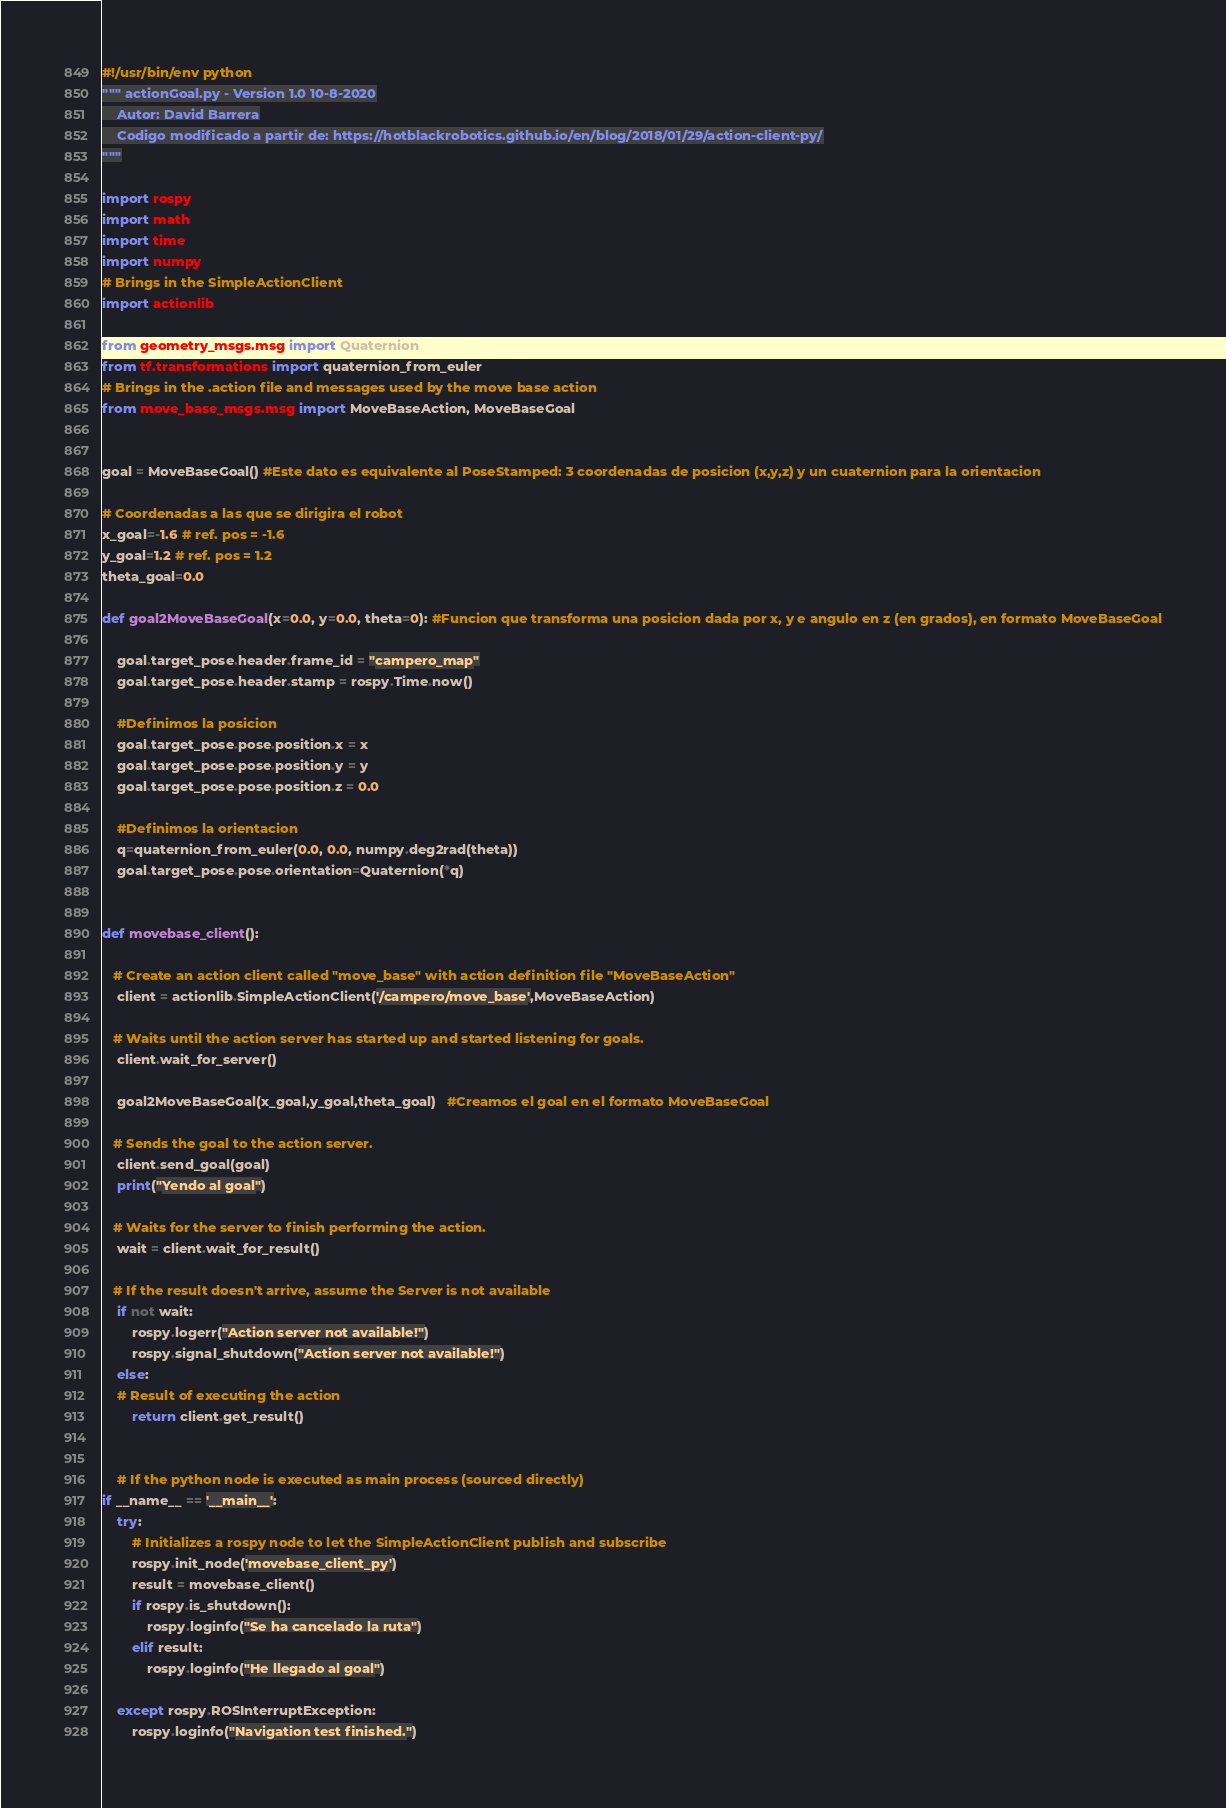<code> <loc_0><loc_0><loc_500><loc_500><_Python_>#!/usr/bin/env python
""" actionGoal.py - Version 1.0 10-8-2020
    Autor: David Barrera
    Codigo modificado a partir de: https://hotblackrobotics.github.io/en/blog/2018/01/29/action-client-py/
"""

import rospy
import math
import time
import numpy
# Brings in the SimpleActionClient
import actionlib

from geometry_msgs.msg import Quaternion
from tf.transformations import quaternion_from_euler
# Brings in the .action file and messages used by the move base action
from move_base_msgs.msg import MoveBaseAction, MoveBaseGoal


goal = MoveBaseGoal() #Este dato es equivalente al PoseStamped: 3 coordenadas de posicion (x,y,z) y un cuaternion para la orientacion

# Coordenadas a las que se dirigira el robot
x_goal=-1.6 # ref. pos = -1.6
y_goal=1.2 # ref. pos = 1.2
theta_goal=0.0

def goal2MoveBaseGoal(x=0.0, y=0.0, theta=0): #Funcion que transforma una posicion dada por x, y e angulo en z (en grados), en formato MoveBaseGoal

    goal.target_pose.header.frame_id = "campero_map"
    goal.target_pose.header.stamp = rospy.Time.now()

    #Definimos la posicion
    goal.target_pose.pose.position.x = x
    goal.target_pose.pose.position.y = y
    goal.target_pose.pose.position.z = 0.0

    #Definimos la orientacion
    q=quaternion_from_euler(0.0, 0.0, numpy.deg2rad(theta))
    goal.target_pose.pose.orientation=Quaternion(*q)


def movebase_client():

   # Create an action client called "move_base" with action definition file "MoveBaseAction"
    client = actionlib.SimpleActionClient('/campero/move_base',MoveBaseAction)

   # Waits until the action server has started up and started listening for goals.
    client.wait_for_server()

    goal2MoveBaseGoal(x_goal,y_goal,theta_goal)   #Creamos el goal en el formato MoveBaseGoal

   # Sends the goal to the action server.
    client.send_goal(goal)
    print("Yendo al goal")

   # Waits for the server to finish performing the action.
    wait = client.wait_for_result()
    
   # If the result doesn't arrive, assume the Server is not available
    if not wait:
        rospy.logerr("Action server not available!")
        rospy.signal_shutdown("Action server not available!")
    else:
    # Result of executing the action
        return client.get_result()   


    # If the python node is executed as main process (sourced directly)
if __name__ == '__main__':
    try:
        # Initializes a rospy node to let the SimpleActionClient publish and subscribe
        rospy.init_node('movebase_client_py')
        result = movebase_client()
        if rospy.is_shutdown():
            rospy.loginfo("Se ha cancelado la ruta")
        elif result:
            rospy.loginfo("He llegado al goal")

    except rospy.ROSInterruptException:
        rospy.loginfo("Navigation test finished.")
</code> 